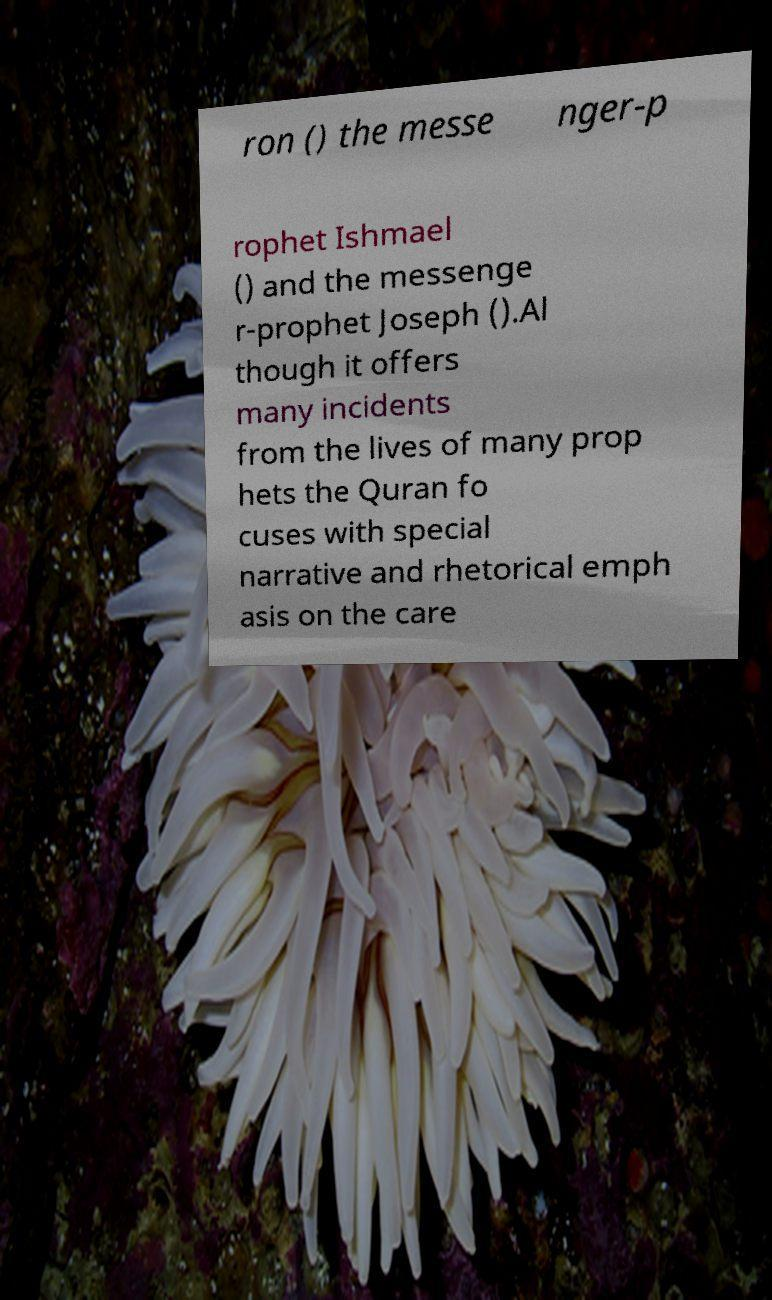For documentation purposes, I need the text within this image transcribed. Could you provide that? ron () the messe nger-p rophet Ishmael () and the messenge r-prophet Joseph ().Al though it offers many incidents from the lives of many prop hets the Quran fo cuses with special narrative and rhetorical emph asis on the care 